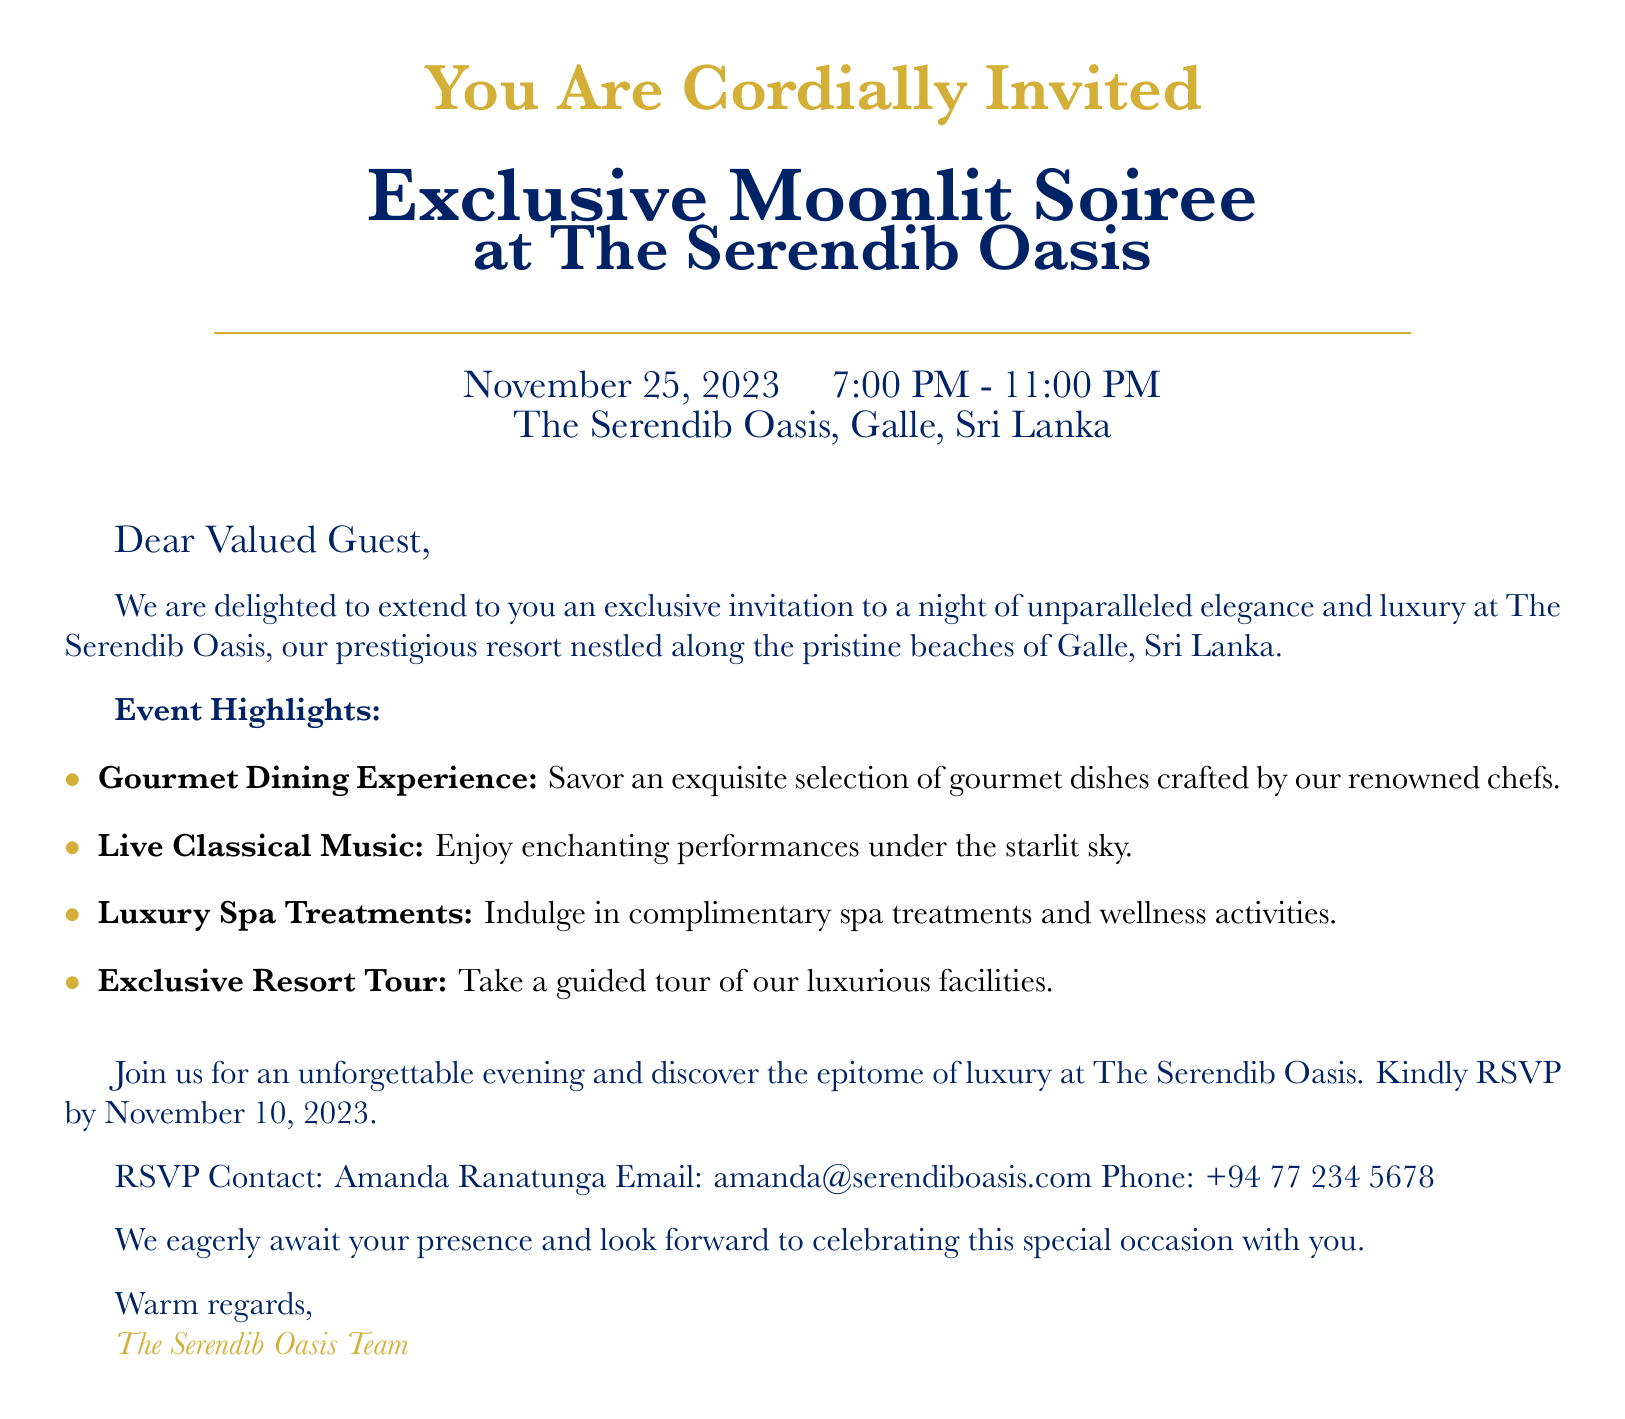What is the event title? The event title is prominently featured in the document under the heading, specifically stating "Exclusive Moonlit Soiree."
Answer: Exclusive Moonlit Soiree What is the date of the event? The date of the event is clearly stated in the document, listed below the title.
Answer: November 25, 2023 What time does the event start? The start time of the event is mentioned along with the ending time, indicated in a large font.
Answer: 7:00 PM Who should guests contact for RSVP? The RSVP contact person is mentioned in the document, specifying who to reach out to for confirming attendance.
Answer: Amanda Ranatunga What types of music will be performed at the event? Information about the musical component of the event is presented under "Event Highlights," indicating the type of music featured.
Answer: Classical Music What kind of dining experience is offered? The document highlights the dining experience and describes its nature in the list of event highlights.
Answer: Gourmet Dining Experience What should guests do by November 10, 2023? The document provides a specific instruction regarding a deadline, indicative of an action required from the guests.
Answer: RSVP What color is used for the main title text? The document specifies the color used for the main title text, which is an essential design aspect.
Answer: Gold foil What is a highlight of the evening that involves relaxation? A specific highlight related to relaxation is listed in the event highlights, pointing to a luxurious offering.
Answer: Luxury Spa Treatments 